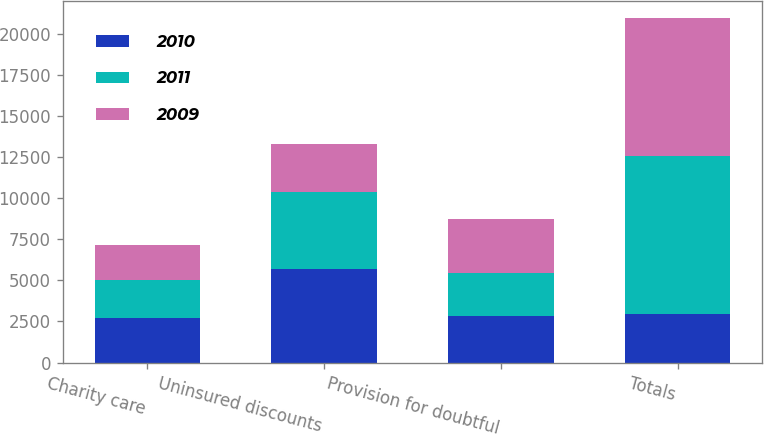Convert chart. <chart><loc_0><loc_0><loc_500><loc_500><stacked_bar_chart><ecel><fcel>Charity care<fcel>Uninsured discounts<fcel>Provision for doubtful<fcel>Totals<nl><fcel>2010<fcel>2683<fcel>5707<fcel>2824<fcel>2935<nl><fcel>2011<fcel>2337<fcel>4641<fcel>2648<fcel>9626<nl><fcel>2009<fcel>2151<fcel>2935<fcel>3276<fcel>8362<nl></chart> 